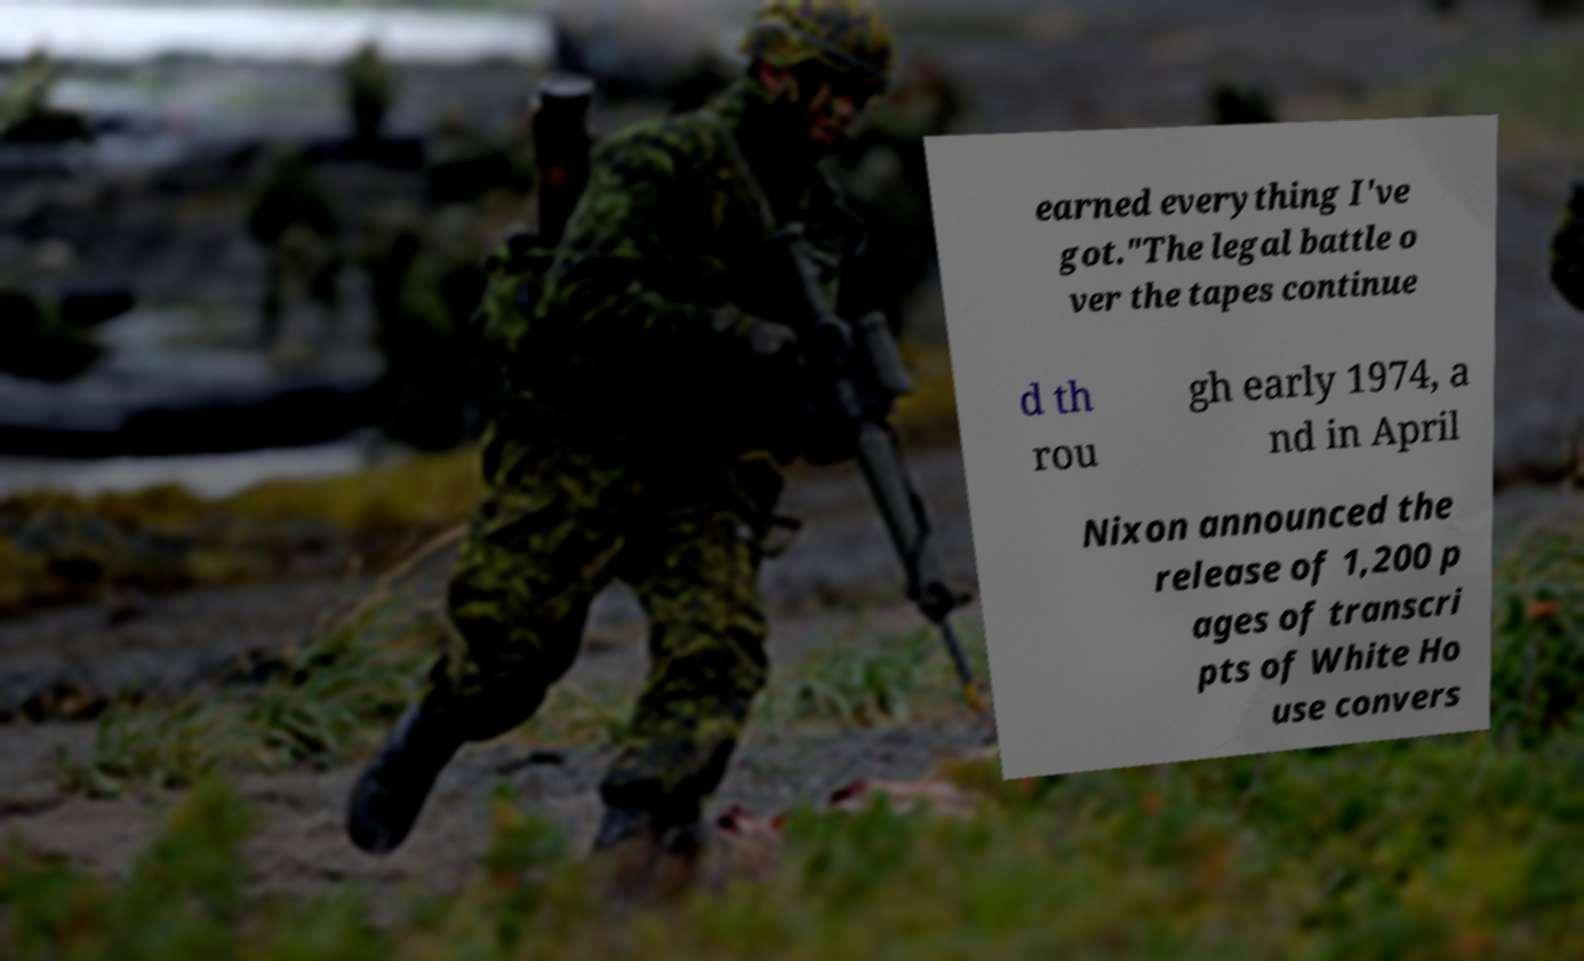Can you accurately transcribe the text from the provided image for me? earned everything I've got."The legal battle o ver the tapes continue d th rou gh early 1974, a nd in April Nixon announced the release of 1,200 p ages of transcri pts of White Ho use convers 